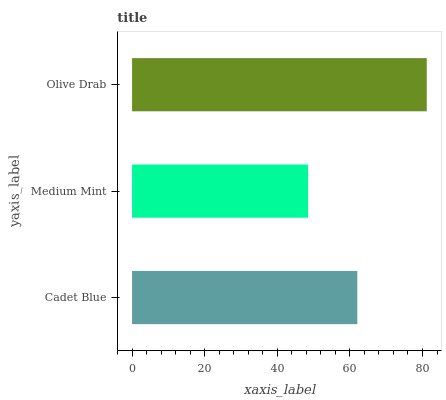Is Medium Mint the minimum?
Answer yes or no. Yes. Is Olive Drab the maximum?
Answer yes or no. Yes. Is Olive Drab the minimum?
Answer yes or no. No. Is Medium Mint the maximum?
Answer yes or no. No. Is Olive Drab greater than Medium Mint?
Answer yes or no. Yes. Is Medium Mint less than Olive Drab?
Answer yes or no. Yes. Is Medium Mint greater than Olive Drab?
Answer yes or no. No. Is Olive Drab less than Medium Mint?
Answer yes or no. No. Is Cadet Blue the high median?
Answer yes or no. Yes. Is Cadet Blue the low median?
Answer yes or no. Yes. Is Olive Drab the high median?
Answer yes or no. No. Is Medium Mint the low median?
Answer yes or no. No. 